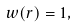Convert formula to latex. <formula><loc_0><loc_0><loc_500><loc_500>w ( r ) = 1 ,</formula> 